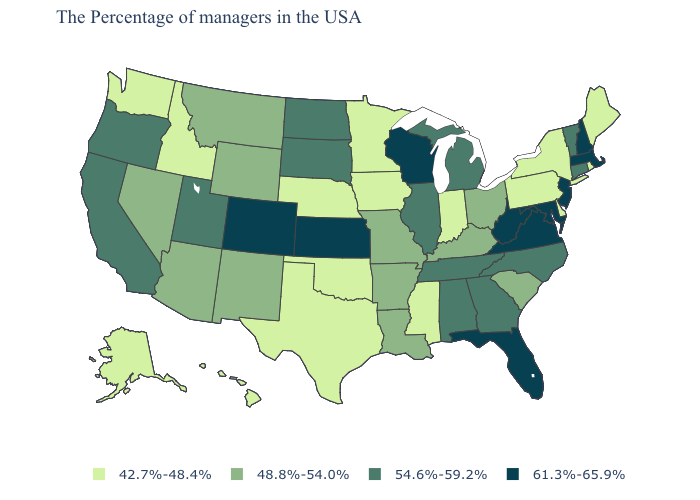Name the states that have a value in the range 61.3%-65.9%?
Give a very brief answer. Massachusetts, New Hampshire, New Jersey, Maryland, Virginia, West Virginia, Florida, Wisconsin, Kansas, Colorado. What is the value of Georgia?
Write a very short answer. 54.6%-59.2%. Which states hav the highest value in the West?
Answer briefly. Colorado. Does New York have a higher value than Illinois?
Give a very brief answer. No. Does New Jersey have a higher value than Colorado?
Be succinct. No. Does Michigan have a higher value than North Carolina?
Short answer required. No. What is the lowest value in the South?
Short answer required. 42.7%-48.4%. What is the lowest value in the MidWest?
Answer briefly. 42.7%-48.4%. How many symbols are there in the legend?
Give a very brief answer. 4. What is the value of Vermont?
Short answer required. 54.6%-59.2%. What is the value of New Jersey?
Be succinct. 61.3%-65.9%. Among the states that border Georgia , which have the lowest value?
Be succinct. South Carolina. Which states have the lowest value in the South?
Be succinct. Delaware, Mississippi, Oklahoma, Texas. Name the states that have a value in the range 54.6%-59.2%?
Keep it brief. Vermont, Connecticut, North Carolina, Georgia, Michigan, Alabama, Tennessee, Illinois, South Dakota, North Dakota, Utah, California, Oregon. Name the states that have a value in the range 54.6%-59.2%?
Give a very brief answer. Vermont, Connecticut, North Carolina, Georgia, Michigan, Alabama, Tennessee, Illinois, South Dakota, North Dakota, Utah, California, Oregon. 